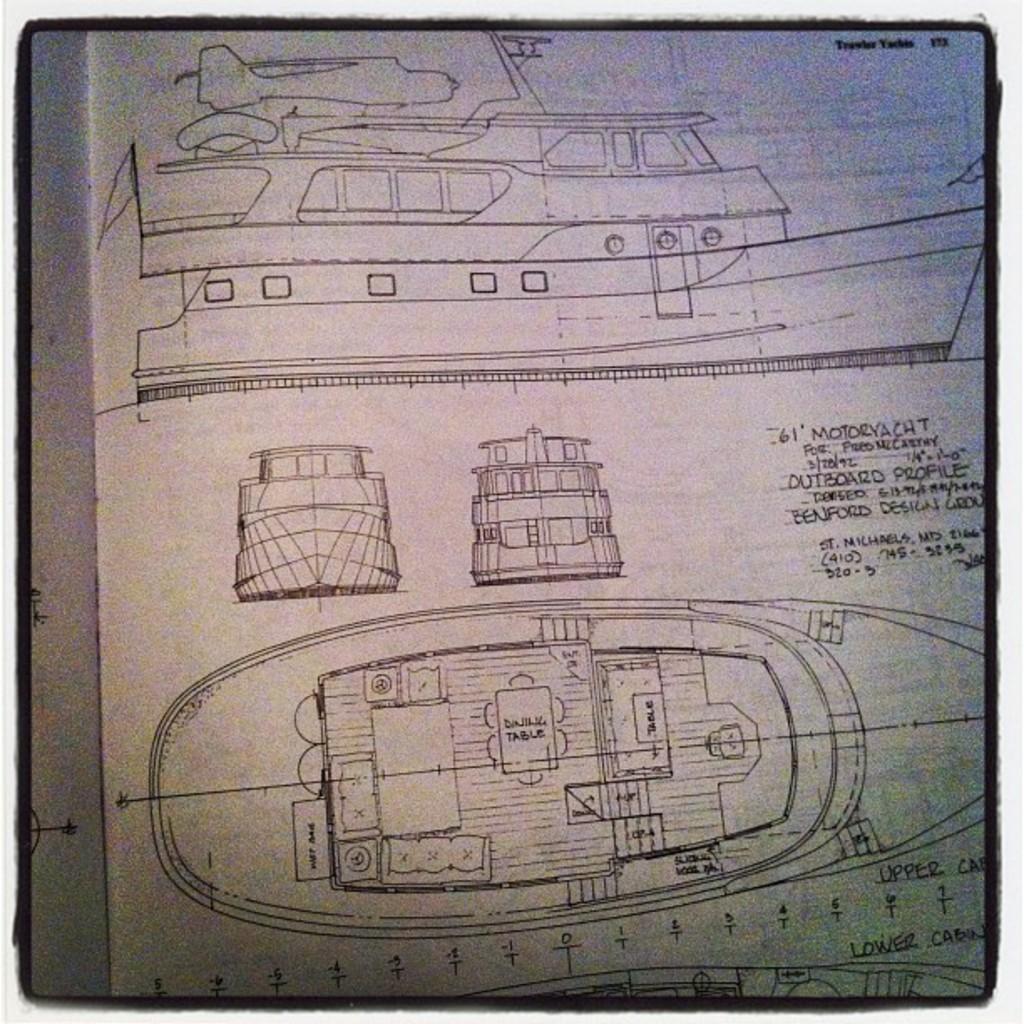How would you summarize this image in a sentence or two? In this picture it looks like some sample designs of boats, ships and their parts on a white paper with some text written on it. 